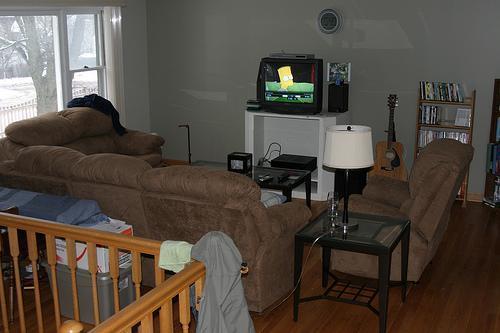How many devices requiring electricity appear to be turned on?
Give a very brief answer. 1. 